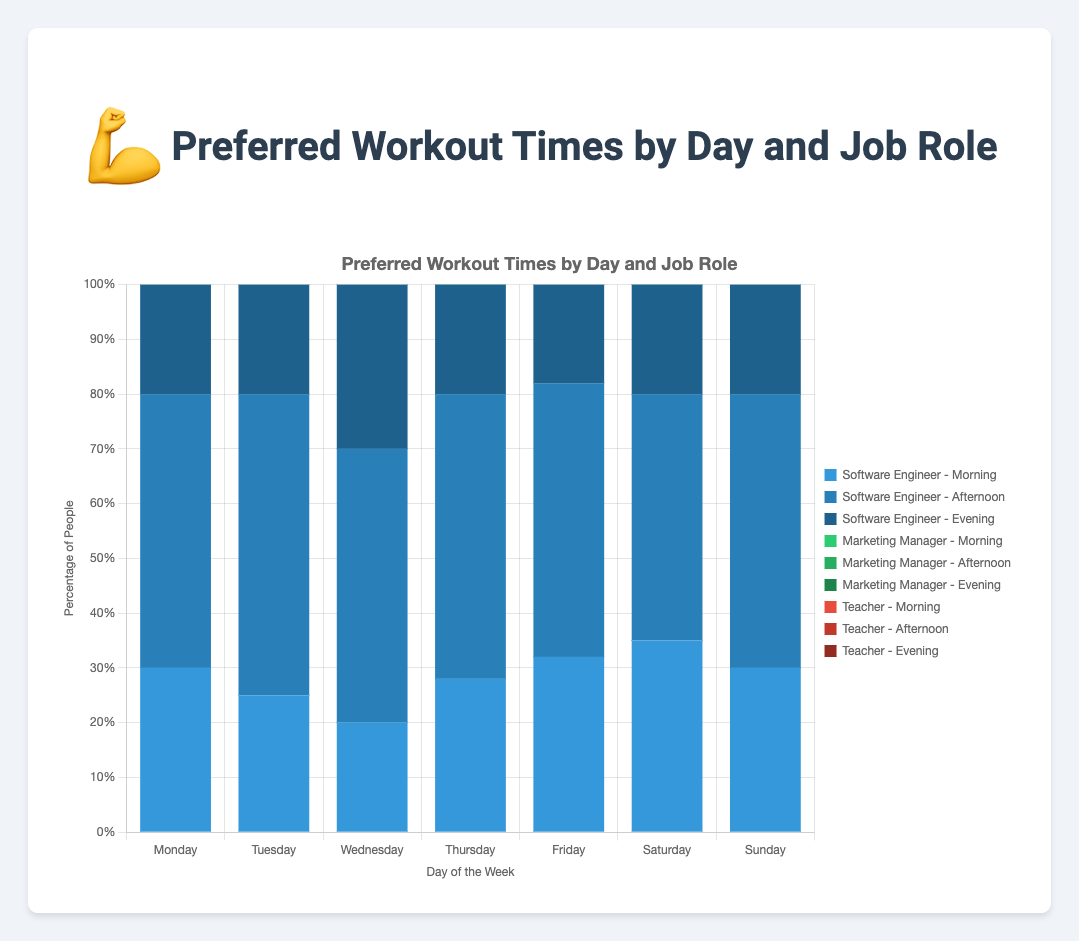What's the most popular workout time for Software Engineers on Wednesday? To find the most popular workout time for Software Engineers on Wednesday, compare the values given for morning, afternoon, and evening. The values are 20 (morning), 50 (afternoon), and 30 (evening). The afternoon has the highest value.
Answer: Afternoon Which job role has the highest percentage of people working out in the morning on Monday? Look at the morning values for each job role on Monday. The values are 30 (Software Engineer), 40 (Marketing Manager), and 35 (Teacher). The Marketing Manager has the highest value.
Answer: Marketing Manager On which day do Teachers prefer working out in the afternoon the most? Check the afternoon values for Teachers on each day. The values are 45 (Monday), 50 (Tuesday), 50 (Wednesday), 48 (Thursday), 45 (Friday), 47 (Saturday), and 52 (Sunday). The highest value is on Sunday.
Answer: Sunday How does the percentage of Software Engineers working out in the evening on Wednesday compare to Thursday? Compare the evening values for Software Engineers on Wednesday and Thursday. The values are 30 (Wednesday) and 20 (Thursday). 30 is greater than 20.
Answer: Wednesday is higher What is the combined percentage of Teachers working out in the morning on weekends? Add the morning values for Teachers on Saturday and Sunday. The values are 34 (Saturday) and 28 (Sunday). The total is 34+28=62.
Answer: 62% Which job role has the least preference for evening workouts throughout the week? By observing the evening workout values through the week for each job role and adding them up, Software Engineer (20+20+30+20+18+20+20=148), Marketing Manager (25+22+25+25+25+23+21=166), and Teacher (20+20+22+22+22+19+20=145). Teachers have the least total.
Answer: Teacher On Friday, which time slot has the smallest difference in the percentage of people working out between Software Engineers and Teachers? Compare the morning, afternoon, and evening values between Software Engineers and Teachers for Friday. Morning: 32 (SE) - 33 (T) = -1, Afternoon: 50 (SE) - 45 (T) = 5, Evening: 18 (SE) - 22 (T) = -4. The smallest difference is in the morning.
Answer: Morning How does the overall afternoon workout preference on Monday compare among the three job roles? Look at the afternoon values on Monday for each job role and sum them up. Software Engineer (50), Marketing Manager (35), and Teacher (45). Total is 50+35+45=130.
Answer: 130 Which day has the most balanced distribution of workout times for Marketing Managers? Find the day where the differences between morning, afternoon, and evening values for Marketing Managers are the smallest. After reviewing each day's values: Monday (40, 35, 25), Tuesday (38, 40, 22), Wednesday (30, 45, 25), Thursday (35, 40, 25), Friday (38, 37, 25), Saturday (37, 40, 23), Sunday (32, 47, 21). Friday has the most balanced values.
Answer: Friday 